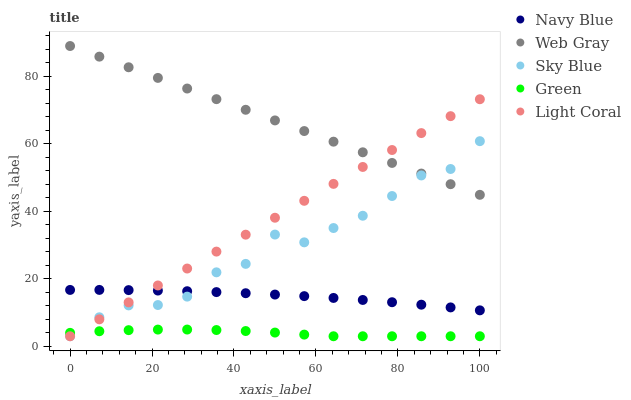Does Green have the minimum area under the curve?
Answer yes or no. Yes. Does Web Gray have the maximum area under the curve?
Answer yes or no. Yes. Does Navy Blue have the minimum area under the curve?
Answer yes or no. No. Does Navy Blue have the maximum area under the curve?
Answer yes or no. No. Is Light Coral the smoothest?
Answer yes or no. Yes. Is Sky Blue the roughest?
Answer yes or no. Yes. Is Navy Blue the smoothest?
Answer yes or no. No. Is Navy Blue the roughest?
Answer yes or no. No. Does Light Coral have the lowest value?
Answer yes or no. Yes. Does Navy Blue have the lowest value?
Answer yes or no. No. Does Web Gray have the highest value?
Answer yes or no. Yes. Does Navy Blue have the highest value?
Answer yes or no. No. Is Green less than Navy Blue?
Answer yes or no. Yes. Is Web Gray greater than Green?
Answer yes or no. Yes. Does Sky Blue intersect Light Coral?
Answer yes or no. Yes. Is Sky Blue less than Light Coral?
Answer yes or no. No. Is Sky Blue greater than Light Coral?
Answer yes or no. No. Does Green intersect Navy Blue?
Answer yes or no. No. 